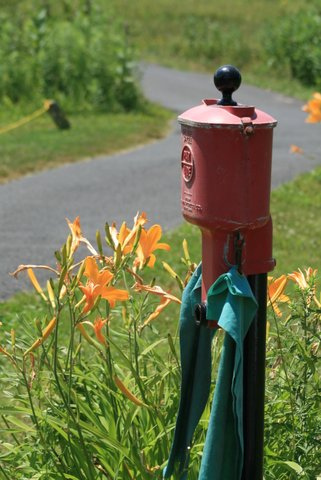<image>
Is there a flower in front of the sign? No. The flower is not in front of the sign. The spatial positioning shows a different relationship between these objects. Is there a flower to the right of the road? Yes. From this viewpoint, the flower is positioned to the right side relative to the road. 